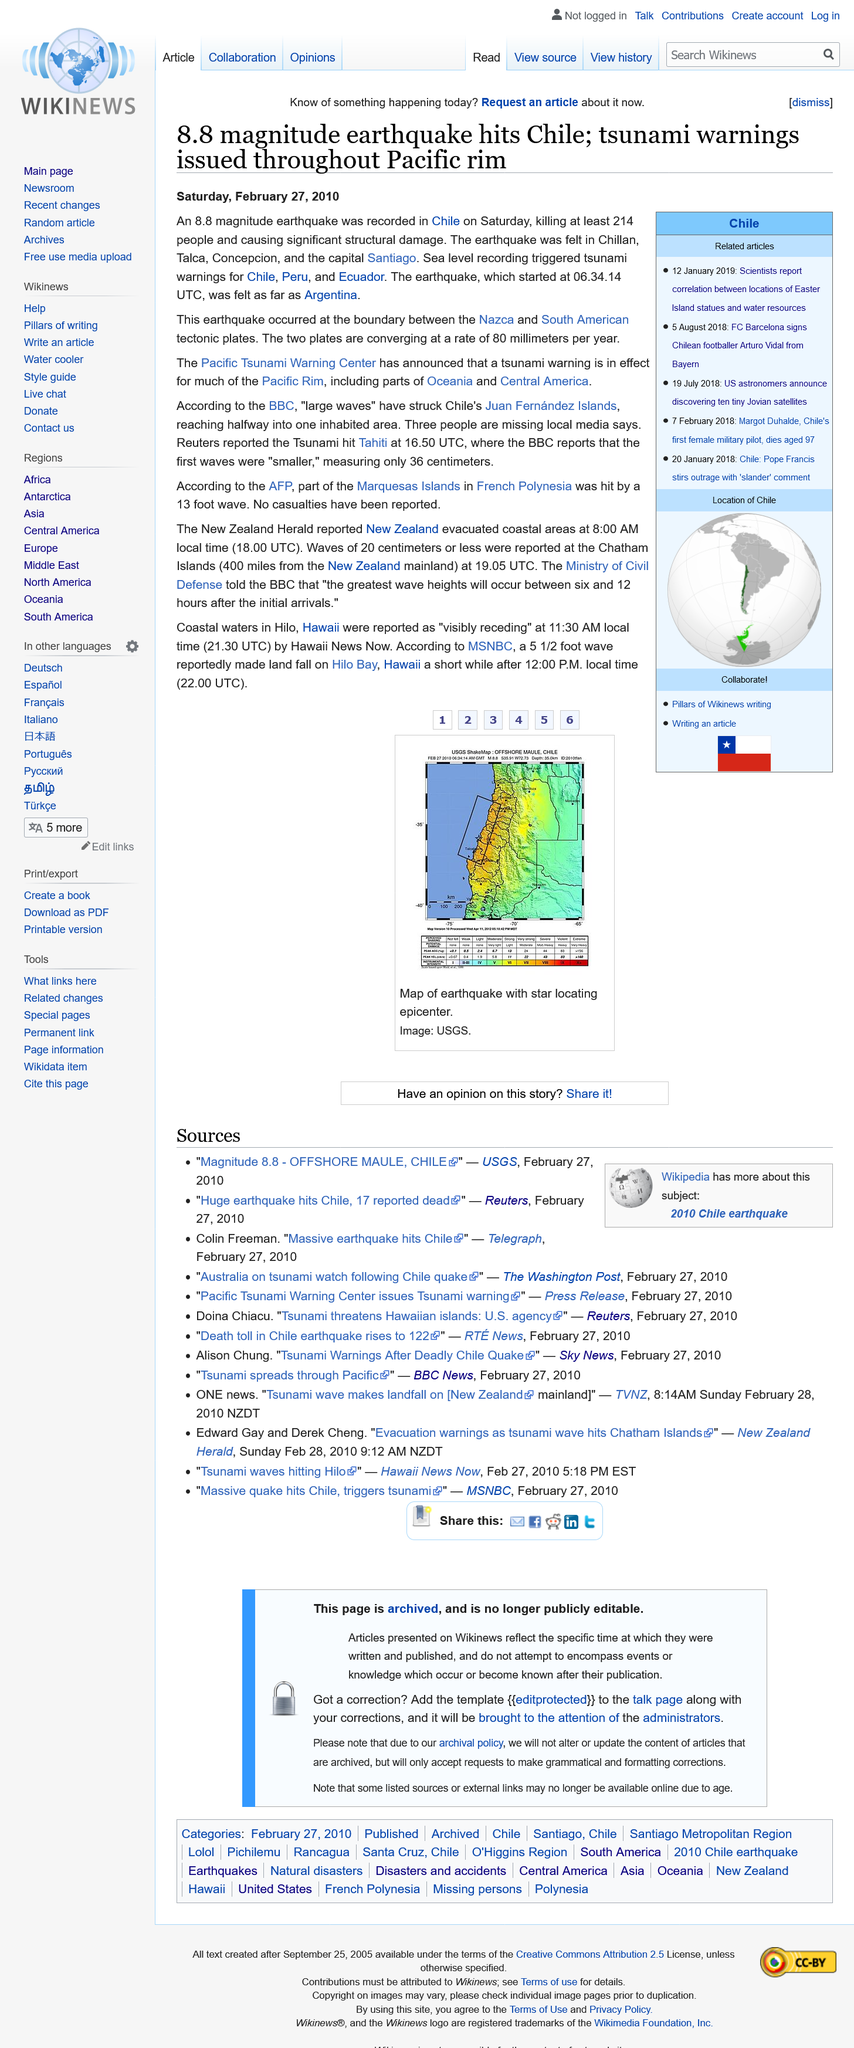Point out several critical features in this image. A magnitude 8.8 earthquake occurred in Chile, making it one of the largest earthquakes on record. In the earthquake, a total of 214 people were killed. On Saturday, February 27, 2010, at 6:34am UTC, an earthquake occurred. 